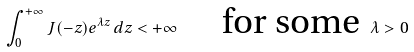<formula> <loc_0><loc_0><loc_500><loc_500>\int _ { 0 } ^ { + \infty } J ( - z ) e ^ { \lambda z } \, d z < + \infty \quad \text { for some } \, \lambda > 0</formula> 